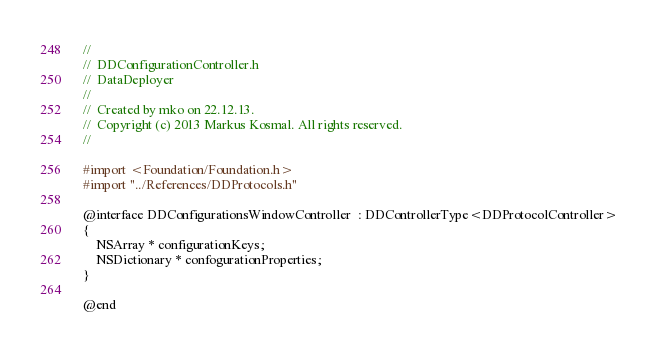<code> <loc_0><loc_0><loc_500><loc_500><_C_>//
//  DDConfigurationController.h
//  DataDeployer
//
//  Created by mko on 22.12.13.
//  Copyright (c) 2013 Markus Kosmal. All rights reserved.
//

#import <Foundation/Foundation.h>
#import "../References/DDProtocols.h"

@interface DDConfigurationsWindowController  : DDControllerType<DDProtocolController>
{
    NSArray * configurationKeys;
    NSDictionary * confogurationProperties;
}

@end
</code> 